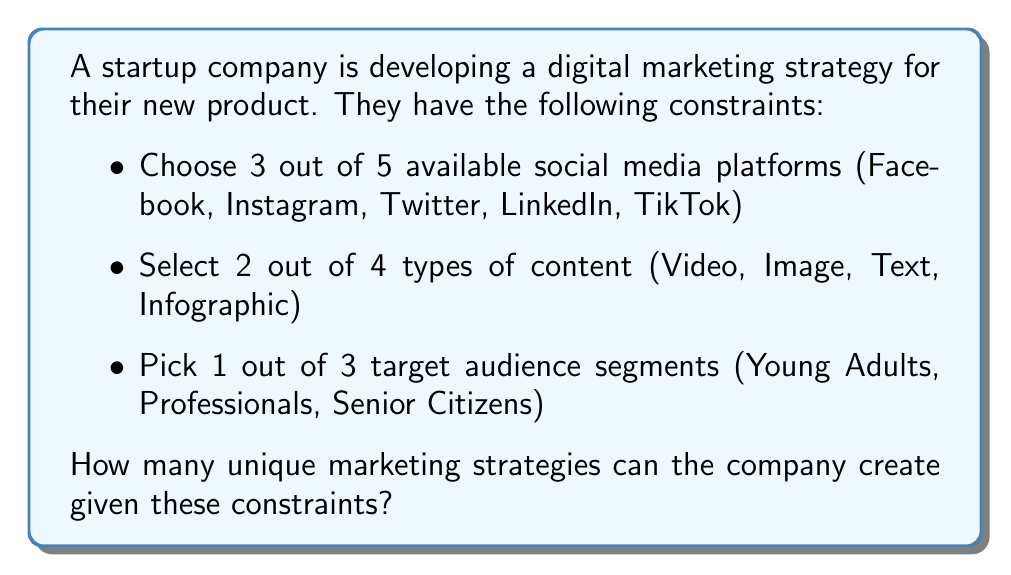What is the answer to this math problem? Let's break this down step-by-step:

1. Choosing social media platforms:
   We need to select 3 platforms out of 5. This is a combination problem.
   Number of ways to choose platforms = $\binom{5}{3} = \frac{5!}{3!(5-3)!} = \frac{5 \cdot 4 \cdot 3}{3 \cdot 2 \cdot 1} = 10$

2. Selecting types of content:
   We need to select 2 types out of 4. Again, this is a combination.
   Number of ways to choose content types = $\binom{4}{2} = \frac{4!}{2!(4-2)!} = \frac{4 \cdot 3}{2 \cdot 1} = 6$

3. Picking target audience:
   We need to select 1 out of 3. This is a simple choice.
   Number of ways to choose audience = $3$

Now, we apply the multiplication principle. For each choice of platforms, we can choose any combination of content types, and for each of those, we can choose any audience.

Total number of unique strategies = $10 \cdot 6 \cdot 3 = 180$
Answer: 180 unique marketing strategies 